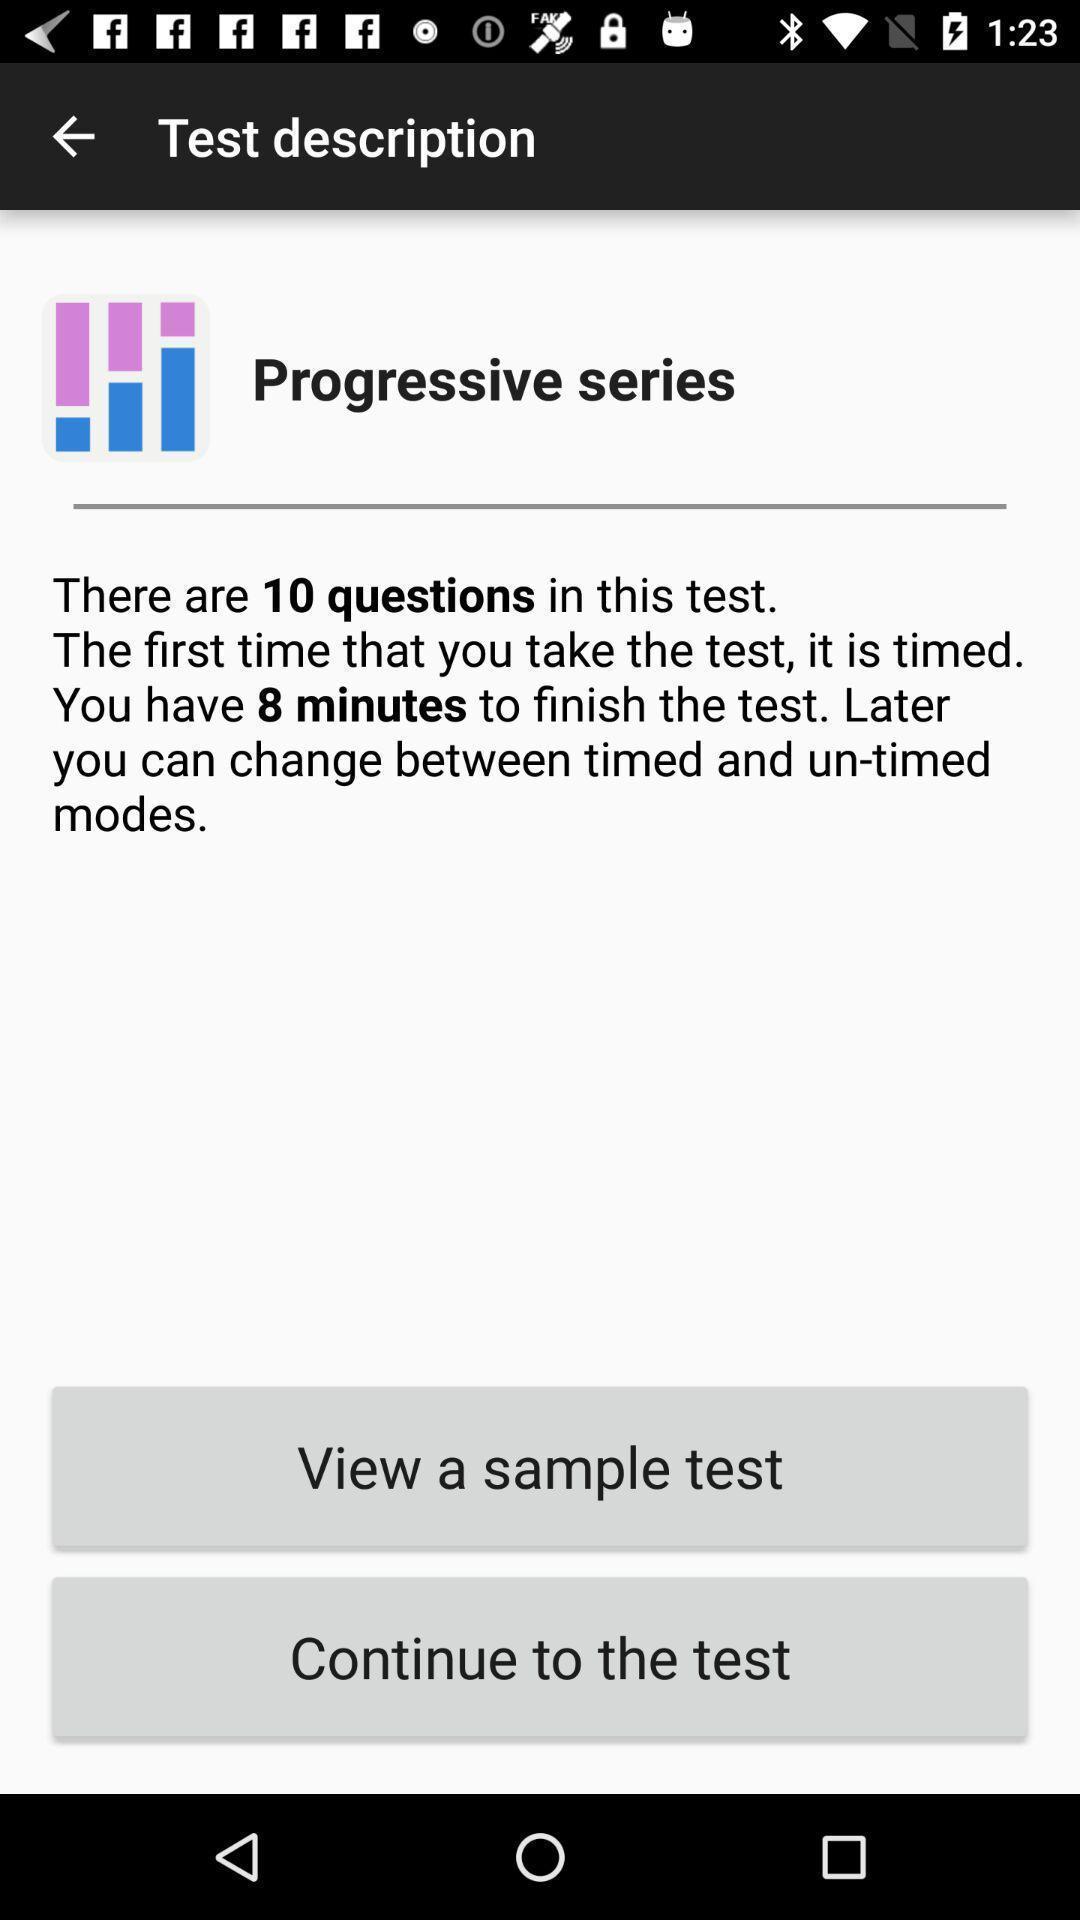Describe this image in words. Page showing description of your test in the education app. 